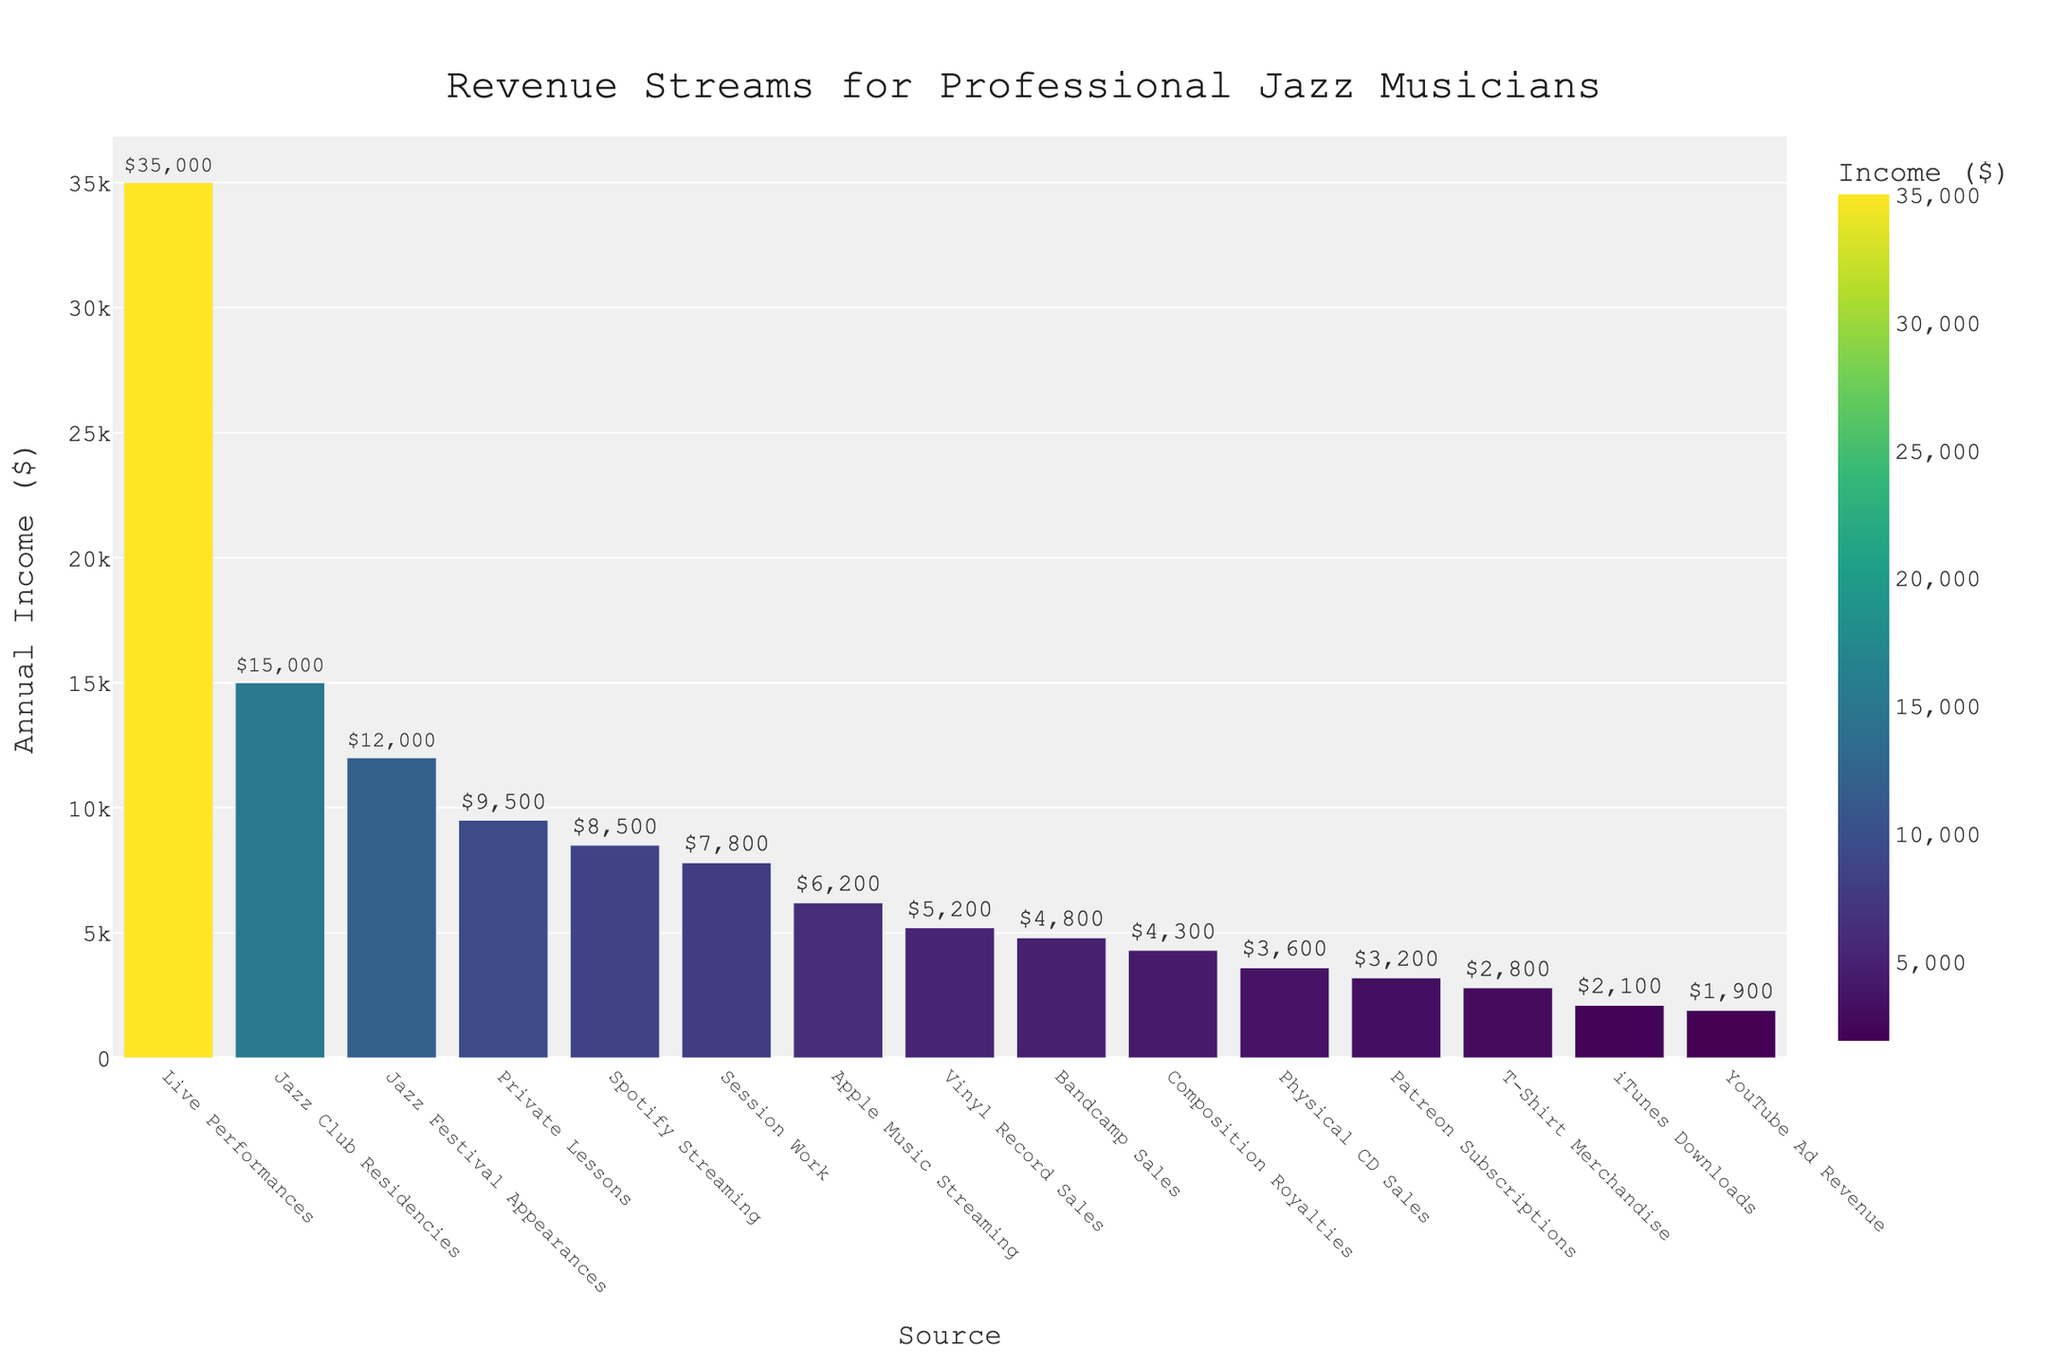Which revenue stream generates the highest annual income for professional jazz musicians? By visually inspecting the height of the bars, the bar representing 'Live Performances' is the tallest, indicating the highest annual income.
Answer: Live Performances Which revenue stream generates the lowest annual income for professional jazz musicians? By identifying the shortest bar, it corresponds to 'YouTube Ad Revenue', indicating it generates the lowest annual income.
Answer: YouTube Ad Revenue How much more annual income do jazz musicians earn from 'Private Lessons' compared to 'Patreon Subscriptions'? 'Private Lessons' generate $9500, and 'Patreon Subscriptions' generate $3200. The difference is calculated as $9500 - $3200.
Answer: $6300 What is the combined annual income from 'Spotify Streaming' and 'Apple Music Streaming'? 'Spotify Streaming' generates $8500 and 'Apple Music Streaming' generates $6200. The sum of these values is $8500 + $6200.
Answer: $14700 Which revenue source between 'Jazz Festival Appearances' and 'Jazz Club Residencies' generates more annual income, and by how much? 'Jazz Festival Appearances' generate $12000, and 'Jazz Club Residencies' generate $15000. The difference is $15000 - $12000.
Answer: Jazz Club Residencies, $3000 Which revenue stream generates higher annual income: 'Vinyl Record Sales' or 'Physical CD Sales'? Comparing the heights of the bars for 'Vinyl Record Sales' and 'Physical CD Sales', 'Vinyl Record Sales' is higher with $5200 compared to $3600 for 'Physical CD Sales'.
Answer: Vinyl Record Sales What is the total annual income from all streaming services combined (Spotify, Apple Music, Bandcamp Sales, iTunes Downloads)? Summing the annual incomes from 'Spotify Streaming' ($8500), 'Apple Music Streaming' ($6200), 'Bandcamp Sales' ($4800), and 'iTunes Downloads' ($2100) results in a total of $8500 + $6200 + $4800 + $2100.
Answer: $21600 Which revenue stream has the closest annual income to $5000? By visually inspecting the bars, 'Vinyl Record Sales' at $5200 is closest to $5000.
Answer: Vinyl Record Sales What is the difference in annual income between 'Composition Royalties' and 'Session Work'? 'Composition Royalties' generate $4300, and 'Session Work' generates $7800. The difference is $7800 - $4300.
Answer: $3500 